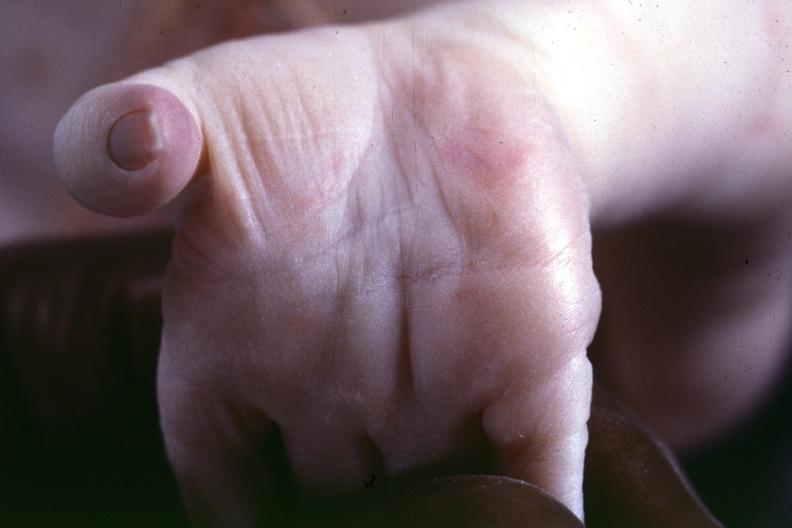s previous slide from this case a simian crease suspect?
Answer the question using a single word or phrase. Yes 